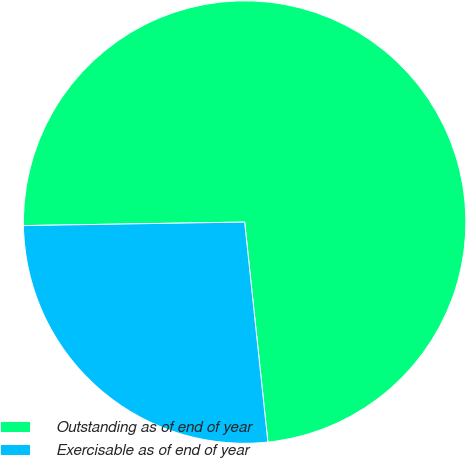Convert chart. <chart><loc_0><loc_0><loc_500><loc_500><pie_chart><fcel>Outstanding as of end of year<fcel>Exercisable as of end of year<nl><fcel>73.58%<fcel>26.42%<nl></chart> 